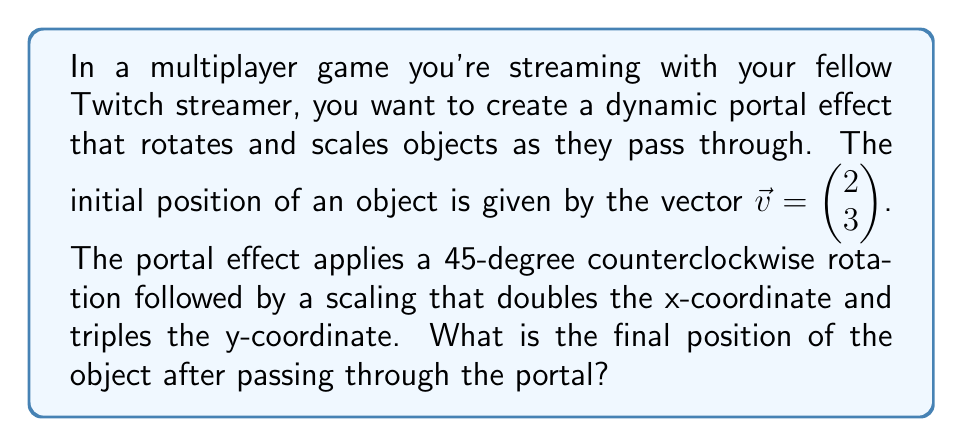Show me your answer to this math problem. To solve this problem, we need to apply two matrix transformations in sequence:

1. Rotation by 45 degrees counterclockwise
2. Scaling by a factor of 2 in the x-direction and 3 in the y-direction

Let's break it down step-by-step:

1. The rotation matrix for a 45-degree counterclockwise rotation is:

   $$R = \begin{pmatrix} \cos 45° & -\sin 45° \\ \sin 45° & \cos 45° \end{pmatrix} = \begin{pmatrix} \frac{\sqrt{2}}{2} & -\frac{\sqrt{2}}{2} \\ \frac{\sqrt{2}}{2} & \frac{\sqrt{2}}{2} \end{pmatrix}$$

2. The scaling matrix for doubling the x-coordinate and tripling the y-coordinate is:

   $$S = \begin{pmatrix} 2 & 0 \\ 0 & 3 \end{pmatrix}$$

3. To apply both transformations, we multiply the matrices in the order of application (scaling after rotation), then multiply by the initial vector:

   $$\vec{v}_{final} = S \cdot R \cdot \vec{v}$$

4. Let's calculate this step-by-step:

   First, apply the rotation:
   $$R \cdot \vec{v} = \begin{pmatrix} \frac{\sqrt{2}}{2} & -\frac{\sqrt{2}}{2} \\ \frac{\sqrt{2}}{2} & \frac{\sqrt{2}}{2} \end{pmatrix} \begin{pmatrix} 2 \\ 3 \end{pmatrix} = \begin{pmatrix} 2\frac{\sqrt{2}}{2} - 3\frac{\sqrt{2}}{2} \\ 2\frac{\sqrt{2}}{2} + 3\frac{\sqrt{2}}{2} \end{pmatrix} = \begin{pmatrix} -\frac{\sqrt{2}}{2} \\ 5\frac{\sqrt{2}}{2} \end{pmatrix}$$

   Then, apply the scaling:
   $$S \cdot (R \cdot \vec{v}) = \begin{pmatrix} 2 & 0 \\ 0 & 3 \end{pmatrix} \begin{pmatrix} -\frac{\sqrt{2}}{2} \\ 5\frac{\sqrt{2}}{2} \end{pmatrix} = \begin{pmatrix} -\sqrt{2} \\ 15\frac{\sqrt{2}}{2} \end{pmatrix}$$

5. Therefore, the final position of the object after passing through the portal is $\begin{pmatrix} -\sqrt{2} \\ 15\frac{\sqrt{2}}{2} \end{pmatrix}$.
Answer: $\begin{pmatrix} -\sqrt{2} \\ 15\frac{\sqrt{2}}{2} \end{pmatrix}$ 